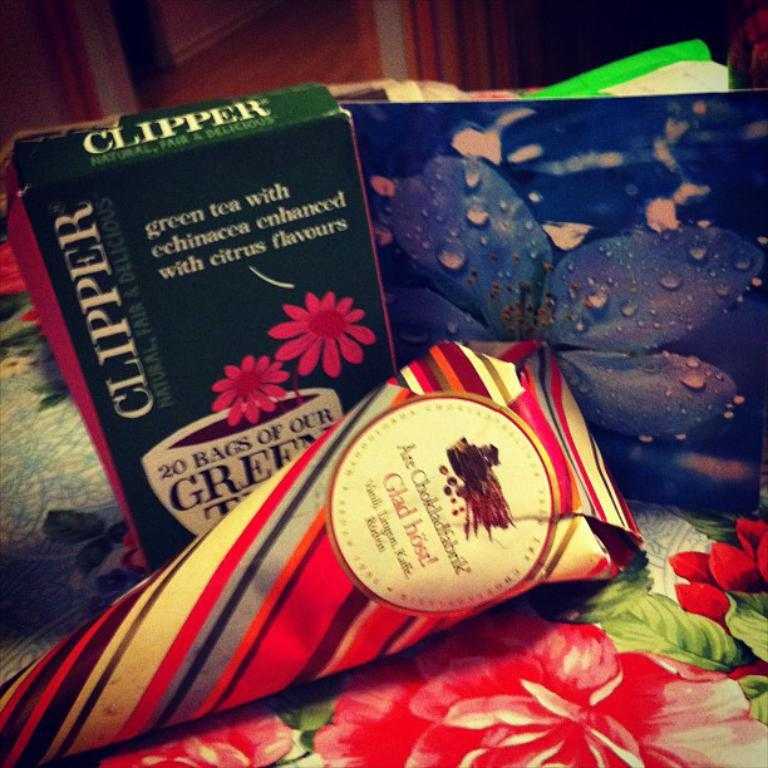What is placed on the cloth in the image? There is a carton, a card, and a paper placed on a cloth in the image. What can be seen on the carton, card, and paper? The specific content of the carton, card, and paper is not mentioned in the facts, so we cannot determine what is on them. What is visible in the background of the image? There is a wall in the background of the image. How many records can be seen on the legs in the image? There are no records or legs present in the image. 